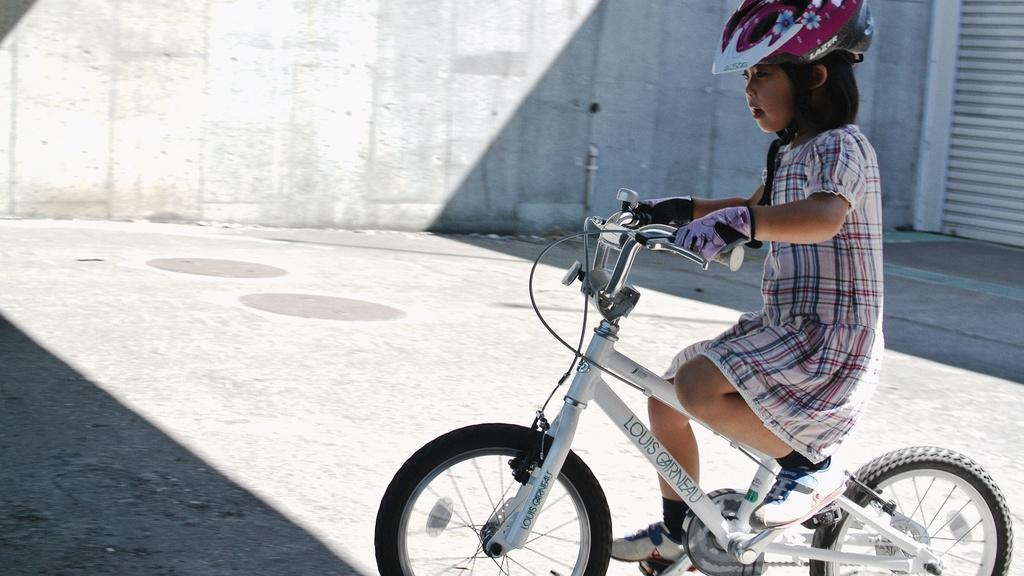Who is the main subject in the foreground of the picture? There is a girl in the foreground of the picture. What is the girl doing in the image? The girl is riding a bicycle. What safety precaution is the girl taking while riding the bicycle? The girl is wearing a helmet. What can be seen in the top right of the image? There is a shutter in the top right of the image. What is visible in the background of the image? There is a wall in the background of the image. How many babies are present in the image? There are no babies present in the image; it features a girl riding a bicycle. What type of sorting activity is happening in the image? There is no sorting activity present in the image. 